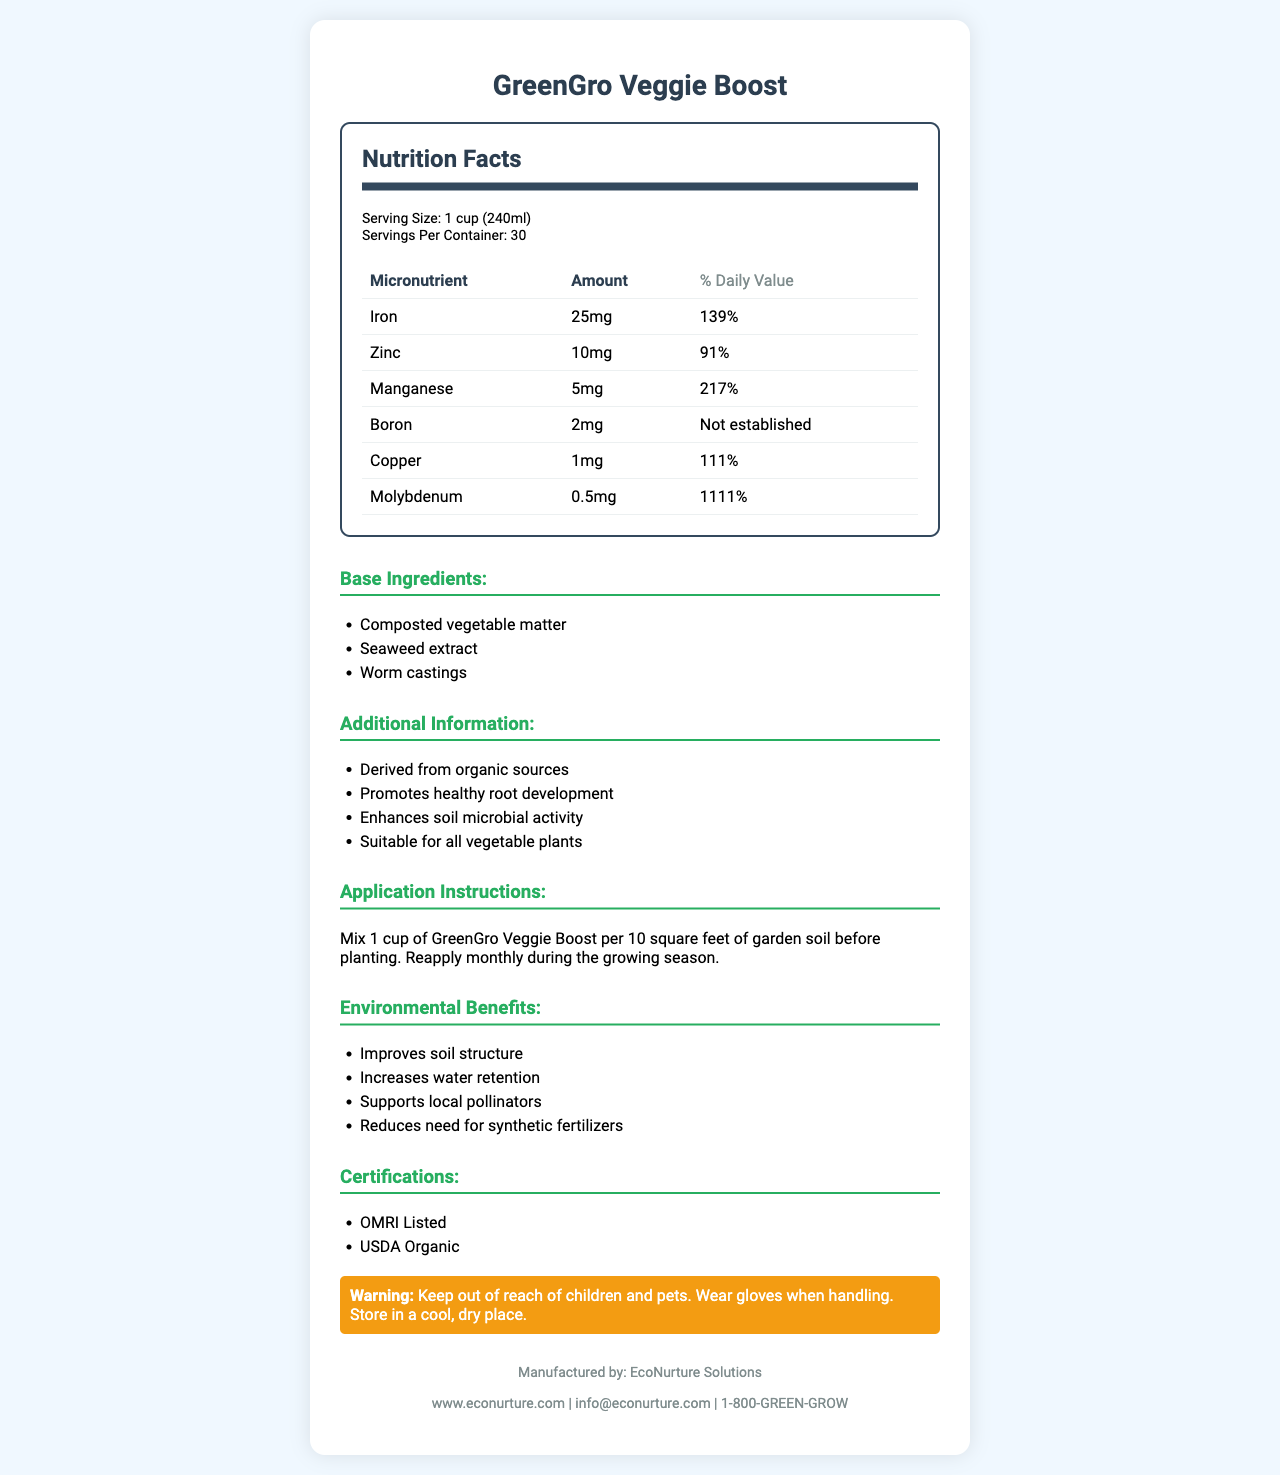Who manufactures GreenGro Veggie Boost? The document clearly states that EcoNurture Solutions is the manufacturer in the manufacturer section.
Answer: EcoNurture Solutions What is the serving size for GreenGro Veggie Boost? The serving size is mentioned at the start of the nutrition facts section.
Answer: 1 cup (240ml) How should GreenGro Veggie Boost be applied? This information is found in the application instructions section.
Answer: Mix 1 cup per 10 square feet of garden soil before planting. Reapply monthly during the growing season. What percentage of the daily value of Iron does one serving provide? The percentage of the daily value for Iron is listed under the micronutrient section.
Answer: 139% Which micronutrient has the highest percentage of daily value? Molybdenum has a daily value of 1111%, which is the highest among the listed micronutrients.
Answer: Molybdenum Which of the following is NOT a base ingredient in GreenGro Veggie Boost? A. Composted vegetable matter B. Seaweed extract C. Fish meal D. Worm castings Fish meal is not listed as a base ingredient; the correct ingredients are composted vegetable matter, seaweed extract, and worm castings.
Answer: C What is the daily value percentage of Zinc? A. 91% B. 111% C. 217% D. 139% The daily value percentage of Zinc is listed as 91%.
Answer: A Does GreenGro Veggie Boost have any certifications? The certification section lists “OMRI Listed” and “USDA Organic” as the certifications.
Answer: Yes Is Boron’s daily value established? The document states that the daily value for Boron is not established.
Answer: No Describe the main purpose and benefits of using GreenGro Veggie Boost. The summary covers the main aspects as observed in the additional information, environmental benefits, and certifications sections.
Answer: GreenGro Veggie Boost is a vegetable-based soil amendment designed to enhance soil fertility and promote healthy plant growth. Derived from organic sources, it provides essential micronutrients and supports local biodiversity. The product's benefits include improved soil structure, increased water retention, enhanced soil microbial activity, and reduced need for synthetic fertilizers. It promotes healthy root development and is suitable for all vegetable plants. What is the contact email for the manufacturer? The contact information section provides this email address.
Answer: info@econurture.com How many servings does one container of GreenGro Veggie Boost provide? This is specified in the serving info section under nutrition facts.
Answer: 30 What are the environmental benefits of GreenGro Veggie Boost? These benefits are listed in the environmental benefits section.
Answer: Improves soil structure, increases water retention, supports local pollinators, reduces need for synthetic fertilizers What is the primary warning associated with GreenGro Veggie Boost? This information is detailed in the warning section.
Answer: Keep out of reach of children and pets. Wear gloves when handling. Store in a cool, dry place. What does the acronym OMRI stand for in the context of the certifications? The document does not specify what OMRI stands for.
Answer: Cannot be determined 